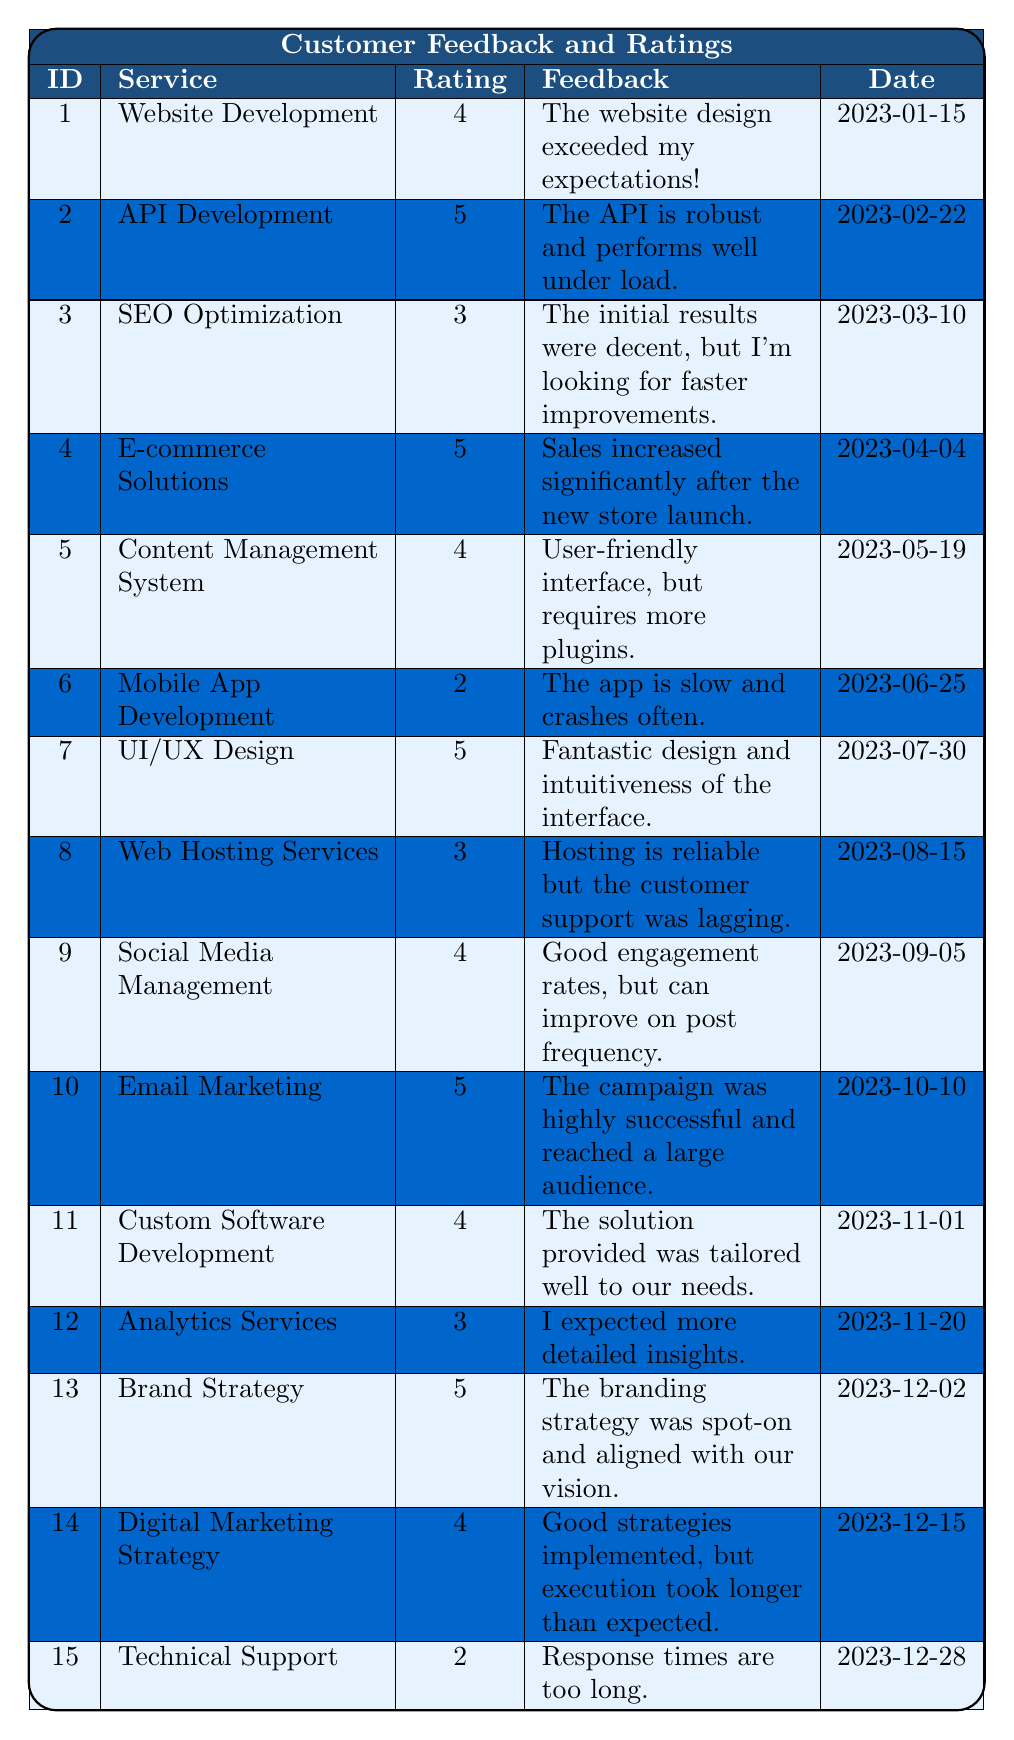What is the highest rating received among the services? The highest rating in the table is 5. By reviewing the ratings, the services "API Development," "E-commerce Solutions," "UI/UX Design," "Email Marketing," "Brand Strategy," and "API Development" all received this rating.
Answer: 5 Which service had the latest customer feedback? The latest feedback is for "Technical Support" on the date 2023-12-28. By scanning the "Date" column, we identify the most recent date listed.
Answer: Technical Support How many services received a rating of 3 or lower? The services rated 3 or lower are "SEO Optimization" (3), "Mobile App Development" (2), "Web Hosting Services" (3), and "Technical Support" (2). There are 4 such ratings.
Answer: 4 What was the average rating of all services? The total sum of the ratings (4 + 5 + 3 + 5 + 4 + 2 + 5 + 3 + 4 + 5 + 4 + 3 + 5 + 4 + 2 = 57) divided by the number of services (15) results in an average rating of 3.8.
Answer: 3.8 Is there any service rated 1? By checking each rating in the table, there is no service that received a 1. Therefore, this statement is false.
Answer: No Which service received the most positive feedback based on the feedback description? The services with positive feedback keywords such as "exceeded my expectations," "robust," "significantly," "fantastic," and "highly successful" suggest high satisfaction. "Brand Strategy" is highlighted as it received a rating of 5 and mentions alignment with vision, indicating a strong positive reaction.
Answer: Brand Strategy How many ratings were 4 out of 5? The count of services rated 4 includes "Website Development," "Content Management System," "Social Media Management," "Custom Software Development," and "Digital Marketing Strategy" which amounts to 5.
Answer: 5 What is the total number of feedback entries for services rated 5? The services rated 5 are "API Development," "E-commerce Solutions," "UI/UX Design," "Email Marketing," and "Brand Strategy," totaling 5 feedback entries.
Answer: 5 Which service had the second lowest rating? The ratings in ascending order are: 2 (Mobile App Development), 2 (Technical Support), 3 (SEO Optimization), 3 (Web Hosting Services), and 3 (Analytics Services). Therefore, "Mobile App Development" and "Technical Support" share the second lowest rating of 2.
Answer: Mobile App Development and Technical Support What percentage of services received ratings of 5? The services receiving ratings of 5 are 6 out of 15 total services. To find the percentage, we take (6/15) * 100 which equals 40%.
Answer: 40% 